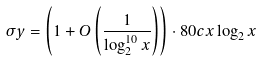<formula> <loc_0><loc_0><loc_500><loc_500>\sigma y = \left ( 1 + O \left ( \frac { 1 } { \log ^ { 1 0 } _ { 2 } x } \right ) \right ) \cdot 8 0 c x \log _ { 2 } x</formula> 